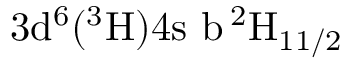<formula> <loc_0><loc_0><loc_500><loc_500>3 d ^ { 6 } ( ^ { 3 } H ) 4 s \ b \, ^ { 2 } H _ { 1 1 / 2 }</formula> 